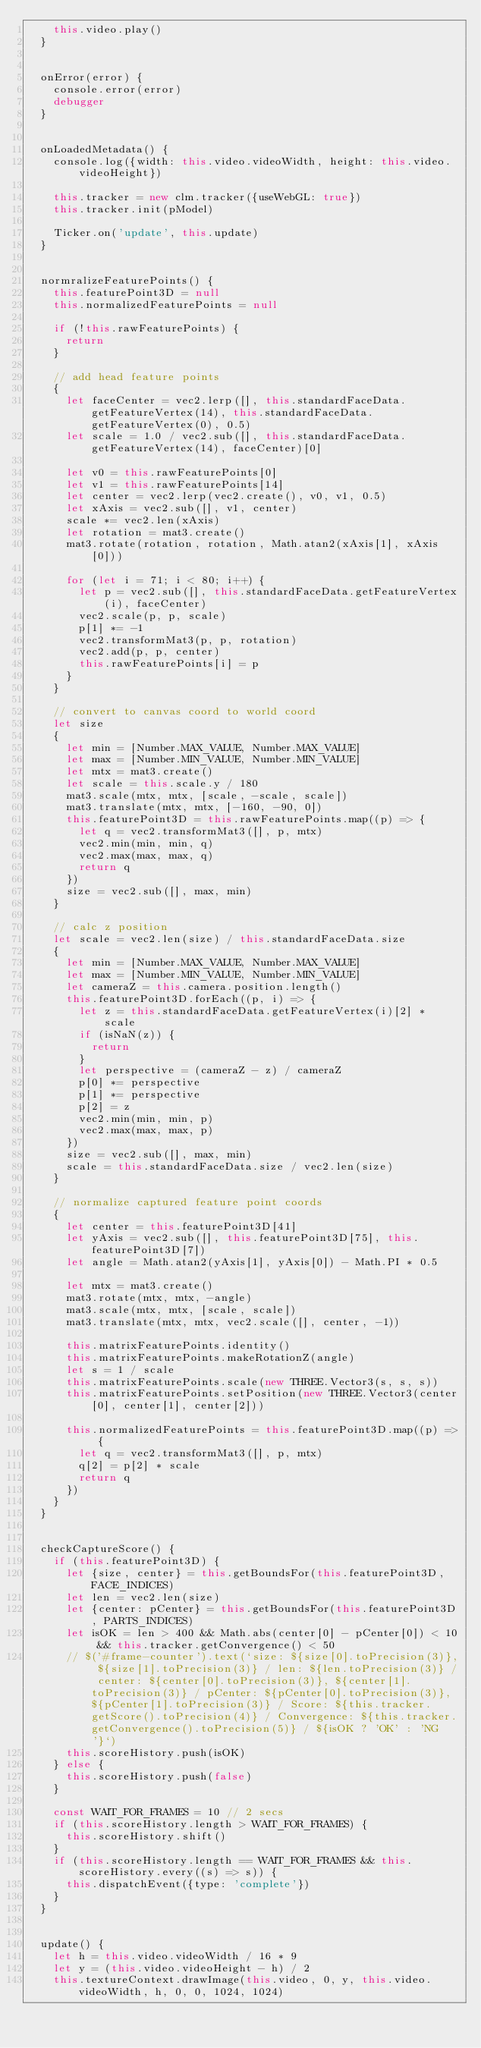Convert code to text. <code><loc_0><loc_0><loc_500><loc_500><_JavaScript_>    this.video.play()
  }


  onError(error) {
    console.error(error)  
    debugger
  }


  onLoadedMetadata() {
    console.log({width: this.video.videoWidth, height: this.video.videoHeight})

    this.tracker = new clm.tracker({useWebGL: true})
    this.tracker.init(pModel)

    Ticker.on('update', this.update)
  }


  normralizeFeaturePoints() {
    this.featurePoint3D = null
    this.normalizedFeaturePoints = null

    if (!this.rawFeaturePoints) {
      return
    }

    // add head feature points
    {
      let faceCenter = vec2.lerp([], this.standardFaceData.getFeatureVertex(14), this.standardFaceData.getFeatureVertex(0), 0.5)
      let scale = 1.0 / vec2.sub([], this.standardFaceData.getFeatureVertex(14), faceCenter)[0]

      let v0 = this.rawFeaturePoints[0]
      let v1 = this.rawFeaturePoints[14]
      let center = vec2.lerp(vec2.create(), v0, v1, 0.5)
      let xAxis = vec2.sub([], v1, center)
      scale *= vec2.len(xAxis)
      let rotation = mat3.create()
      mat3.rotate(rotation, rotation, Math.atan2(xAxis[1], xAxis[0]))

      for (let i = 71; i < 80; i++) {
        let p = vec2.sub([], this.standardFaceData.getFeatureVertex(i), faceCenter)
        vec2.scale(p, p, scale)
        p[1] *= -1
        vec2.transformMat3(p, p, rotation)
        vec2.add(p, p, center)
        this.rawFeaturePoints[i] = p
      }
    }

    // convert to canvas coord to world coord
    let size
    {
      let min = [Number.MAX_VALUE, Number.MAX_VALUE]
      let max = [Number.MIN_VALUE, Number.MIN_VALUE]
      let mtx = mat3.create()
      let scale = this.scale.y / 180
      mat3.scale(mtx, mtx, [scale, -scale, scale])
      mat3.translate(mtx, mtx, [-160, -90, 0])
      this.featurePoint3D = this.rawFeaturePoints.map((p) => {
        let q = vec2.transformMat3([], p, mtx)
        vec2.min(min, min, q)
        vec2.max(max, max, q)
        return q
      })
      size = vec2.sub([], max, min)
    }

    // calc z position
    let scale = vec2.len(size) / this.standardFaceData.size
    {
      let min = [Number.MAX_VALUE, Number.MAX_VALUE]
      let max = [Number.MIN_VALUE, Number.MIN_VALUE]
      let cameraZ = this.camera.position.length()
      this.featurePoint3D.forEach((p, i) => {
        let z = this.standardFaceData.getFeatureVertex(i)[2] * scale
        if (isNaN(z)) {
          return
        }
        let perspective = (cameraZ - z) / cameraZ
        p[0] *= perspective
        p[1] *= perspective
        p[2] = z
        vec2.min(min, min, p)
        vec2.max(max, max, p)
      })
      size = vec2.sub([], max, min)
      scale = this.standardFaceData.size / vec2.len(size)
    }

    // normalize captured feature point coords
    {
      let center = this.featurePoint3D[41]
      let yAxis = vec2.sub([], this.featurePoint3D[75], this.featurePoint3D[7])
      let angle = Math.atan2(yAxis[1], yAxis[0]) - Math.PI * 0.5

      let mtx = mat3.create()
      mat3.rotate(mtx, mtx, -angle)
      mat3.scale(mtx, mtx, [scale, scale])
      mat3.translate(mtx, mtx, vec2.scale([], center, -1))

      this.matrixFeaturePoints.identity()
      this.matrixFeaturePoints.makeRotationZ(angle)
      let s = 1 / scale
      this.matrixFeaturePoints.scale(new THREE.Vector3(s, s, s))
      this.matrixFeaturePoints.setPosition(new THREE.Vector3(center[0], center[1], center[2]))

      this.normalizedFeaturePoints = this.featurePoint3D.map((p) => {
        let q = vec2.transformMat3([], p, mtx)
        q[2] = p[2] * scale
        return q
      })
    }
  }


  checkCaptureScore() {
    if (this.featurePoint3D) {
      let {size, center} = this.getBoundsFor(this.featurePoint3D, FACE_INDICES)
      let len = vec2.len(size)
      let {center: pCenter} = this.getBoundsFor(this.featurePoint3D, PARTS_INDICES)
      let isOK = len > 400 && Math.abs(center[0] - pCenter[0]) < 10 && this.tracker.getConvergence() < 50
      // $('#frame-counter').text(`size: ${size[0].toPrecision(3)}, ${size[1].toPrecision(3)} / len: ${len.toPrecision(3)} / center: ${center[0].toPrecision(3)}, ${center[1].toPrecision(3)} / pCenter: ${pCenter[0].toPrecision(3)}, ${pCenter[1].toPrecision(3)} / Score: ${this.tracker.getScore().toPrecision(4)} / Convergence: ${this.tracker.getConvergence().toPrecision(5)} / ${isOK ? 'OK' : 'NG'}`)
      this.scoreHistory.push(isOK)
    } else {
      this.scoreHistory.push(false)
    }

    const WAIT_FOR_FRAMES = 10 // 2 secs
    if (this.scoreHistory.length > WAIT_FOR_FRAMES) {
      this.scoreHistory.shift()
    }
    if (this.scoreHistory.length == WAIT_FOR_FRAMES && this.scoreHistory.every((s) => s)) {
      this.dispatchEvent({type: 'complete'})
    }
  }


  update() {
    let h = this.video.videoWidth / 16 * 9
    let y = (this.video.videoHeight - h) / 2
    this.textureContext.drawImage(this.video, 0, y, this.video.videoWidth, h, 0, 0, 1024, 1024)
</code> 